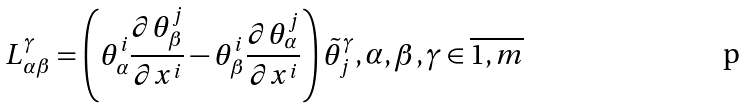<formula> <loc_0><loc_0><loc_500><loc_500>L _ { \alpha \beta } ^ { \gamma } = \left ( \theta _ { \alpha } ^ { i } \frac { \partial \theta _ { \beta } ^ { j } } { \partial x ^ { i } } - \theta _ { \beta } ^ { i } \frac { \partial \theta _ { \alpha } ^ { j } } { \partial x ^ { i } } \right ) \tilde { \theta } _ { j } ^ { \gamma } , \alpha , \beta , \gamma \in \overline { 1 , m }</formula> 